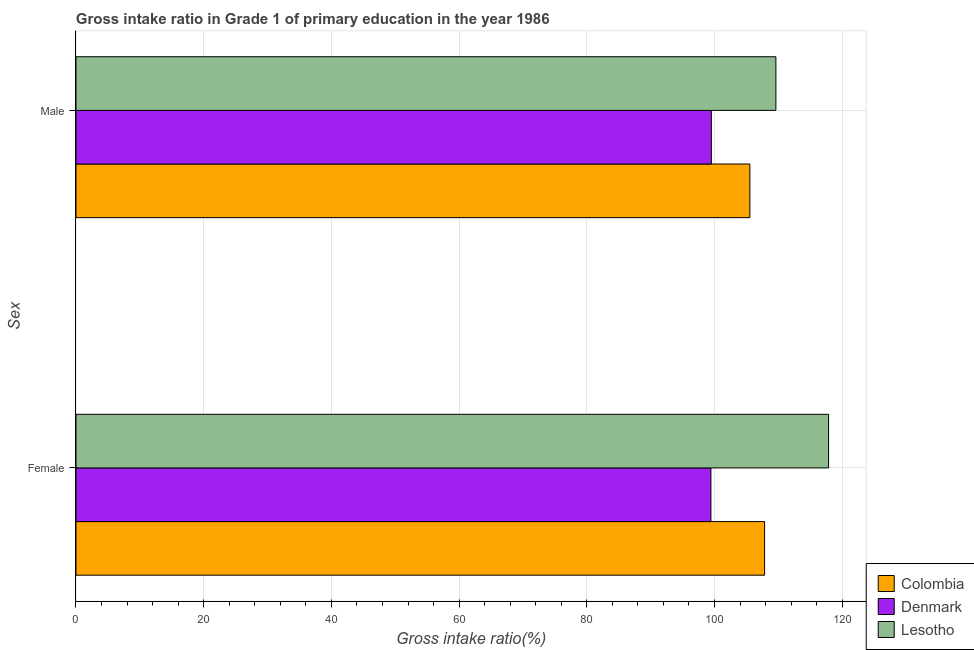How many groups of bars are there?
Give a very brief answer. 2. How many bars are there on the 2nd tick from the top?
Give a very brief answer. 3. What is the label of the 1st group of bars from the top?
Your response must be concise. Male. What is the gross intake ratio(male) in Lesotho?
Provide a succinct answer. 109.61. Across all countries, what is the maximum gross intake ratio(male)?
Provide a succinct answer. 109.61. Across all countries, what is the minimum gross intake ratio(male)?
Give a very brief answer. 99.51. In which country was the gross intake ratio(male) maximum?
Your response must be concise. Lesotho. What is the total gross intake ratio(female) in the graph?
Your answer should be very brief. 325.15. What is the difference between the gross intake ratio(female) in Denmark and that in Lesotho?
Make the answer very short. -18.43. What is the difference between the gross intake ratio(female) in Denmark and the gross intake ratio(male) in Lesotho?
Give a very brief answer. -10.18. What is the average gross intake ratio(female) per country?
Provide a short and direct response. 108.38. What is the difference between the gross intake ratio(male) and gross intake ratio(female) in Colombia?
Your answer should be very brief. -2.31. What is the ratio of the gross intake ratio(male) in Colombia to that in Lesotho?
Ensure brevity in your answer.  0.96. What does the 2nd bar from the top in Male represents?
Offer a terse response. Denmark. What does the 3rd bar from the bottom in Female represents?
Provide a succinct answer. Lesotho. How many bars are there?
Your response must be concise. 6. Are all the bars in the graph horizontal?
Give a very brief answer. Yes. What is the difference between two consecutive major ticks on the X-axis?
Keep it short and to the point. 20. Are the values on the major ticks of X-axis written in scientific E-notation?
Provide a succinct answer. No. Does the graph contain grids?
Offer a very short reply. Yes. How many legend labels are there?
Make the answer very short. 3. What is the title of the graph?
Your answer should be very brief. Gross intake ratio in Grade 1 of primary education in the year 1986. What is the label or title of the X-axis?
Make the answer very short. Gross intake ratio(%). What is the label or title of the Y-axis?
Make the answer very short. Sex. What is the Gross intake ratio(%) of Colombia in Female?
Ensure brevity in your answer.  107.85. What is the Gross intake ratio(%) in Denmark in Female?
Your response must be concise. 99.44. What is the Gross intake ratio(%) in Lesotho in Female?
Your answer should be very brief. 117.87. What is the Gross intake ratio(%) of Colombia in Male?
Make the answer very short. 105.54. What is the Gross intake ratio(%) of Denmark in Male?
Provide a short and direct response. 99.51. What is the Gross intake ratio(%) in Lesotho in Male?
Your answer should be very brief. 109.61. Across all Sex, what is the maximum Gross intake ratio(%) of Colombia?
Ensure brevity in your answer.  107.85. Across all Sex, what is the maximum Gross intake ratio(%) of Denmark?
Your response must be concise. 99.51. Across all Sex, what is the maximum Gross intake ratio(%) of Lesotho?
Ensure brevity in your answer.  117.87. Across all Sex, what is the minimum Gross intake ratio(%) in Colombia?
Make the answer very short. 105.54. Across all Sex, what is the minimum Gross intake ratio(%) of Denmark?
Provide a short and direct response. 99.44. Across all Sex, what is the minimum Gross intake ratio(%) of Lesotho?
Your answer should be very brief. 109.61. What is the total Gross intake ratio(%) of Colombia in the graph?
Keep it short and to the point. 213.39. What is the total Gross intake ratio(%) of Denmark in the graph?
Your response must be concise. 198.94. What is the total Gross intake ratio(%) in Lesotho in the graph?
Offer a terse response. 227.48. What is the difference between the Gross intake ratio(%) in Colombia in Female and that in Male?
Your answer should be compact. 2.31. What is the difference between the Gross intake ratio(%) of Denmark in Female and that in Male?
Ensure brevity in your answer.  -0.07. What is the difference between the Gross intake ratio(%) of Lesotho in Female and that in Male?
Keep it short and to the point. 8.25. What is the difference between the Gross intake ratio(%) in Colombia in Female and the Gross intake ratio(%) in Denmark in Male?
Provide a short and direct response. 8.34. What is the difference between the Gross intake ratio(%) of Colombia in Female and the Gross intake ratio(%) of Lesotho in Male?
Ensure brevity in your answer.  -1.77. What is the difference between the Gross intake ratio(%) of Denmark in Female and the Gross intake ratio(%) of Lesotho in Male?
Your answer should be compact. -10.18. What is the average Gross intake ratio(%) of Colombia per Sex?
Provide a short and direct response. 106.69. What is the average Gross intake ratio(%) in Denmark per Sex?
Ensure brevity in your answer.  99.47. What is the average Gross intake ratio(%) in Lesotho per Sex?
Your response must be concise. 113.74. What is the difference between the Gross intake ratio(%) of Colombia and Gross intake ratio(%) of Denmark in Female?
Your answer should be very brief. 8.41. What is the difference between the Gross intake ratio(%) of Colombia and Gross intake ratio(%) of Lesotho in Female?
Offer a terse response. -10.02. What is the difference between the Gross intake ratio(%) of Denmark and Gross intake ratio(%) of Lesotho in Female?
Your response must be concise. -18.43. What is the difference between the Gross intake ratio(%) of Colombia and Gross intake ratio(%) of Denmark in Male?
Keep it short and to the point. 6.03. What is the difference between the Gross intake ratio(%) in Colombia and Gross intake ratio(%) in Lesotho in Male?
Provide a succinct answer. -4.07. What is the difference between the Gross intake ratio(%) of Denmark and Gross intake ratio(%) of Lesotho in Male?
Keep it short and to the point. -10.11. What is the ratio of the Gross intake ratio(%) of Colombia in Female to that in Male?
Offer a very short reply. 1.02. What is the ratio of the Gross intake ratio(%) of Lesotho in Female to that in Male?
Your answer should be compact. 1.08. What is the difference between the highest and the second highest Gross intake ratio(%) of Colombia?
Offer a terse response. 2.31. What is the difference between the highest and the second highest Gross intake ratio(%) of Denmark?
Keep it short and to the point. 0.07. What is the difference between the highest and the second highest Gross intake ratio(%) in Lesotho?
Offer a terse response. 8.25. What is the difference between the highest and the lowest Gross intake ratio(%) of Colombia?
Give a very brief answer. 2.31. What is the difference between the highest and the lowest Gross intake ratio(%) in Denmark?
Keep it short and to the point. 0.07. What is the difference between the highest and the lowest Gross intake ratio(%) of Lesotho?
Your answer should be compact. 8.25. 